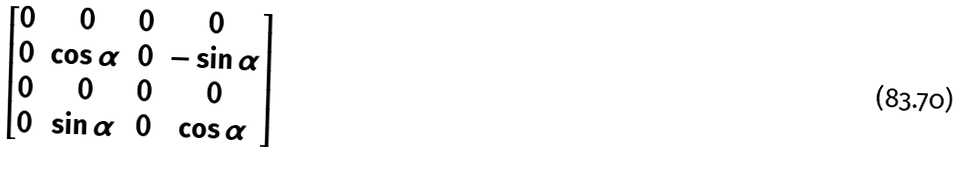Convert formula to latex. <formula><loc_0><loc_0><loc_500><loc_500>\begin{bmatrix} 0 & 0 & 0 & 0 \\ 0 & \cos \alpha & 0 & - \sin \alpha \\ 0 & 0 & 0 & 0 \\ 0 & \sin \alpha & 0 & \cos \alpha \end{bmatrix}</formula> 